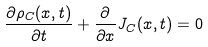Convert formula to latex. <formula><loc_0><loc_0><loc_500><loc_500>\frac { \partial { \rho _ { C } } ( x , t ) } { \partial t } + \frac { \partial } { \partial x } { J _ { C } } ( x , t ) = 0</formula> 